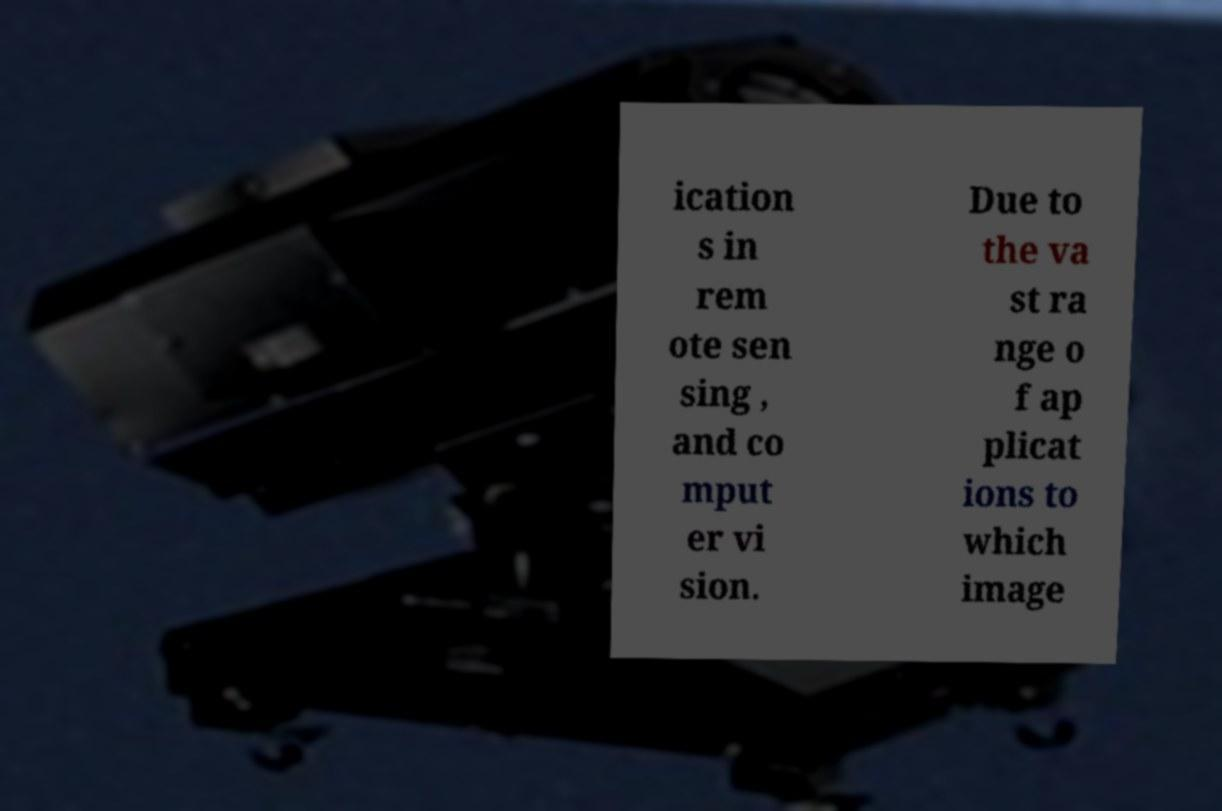Please read and relay the text visible in this image. What does it say? ication s in rem ote sen sing , and co mput er vi sion. Due to the va st ra nge o f ap plicat ions to which image 